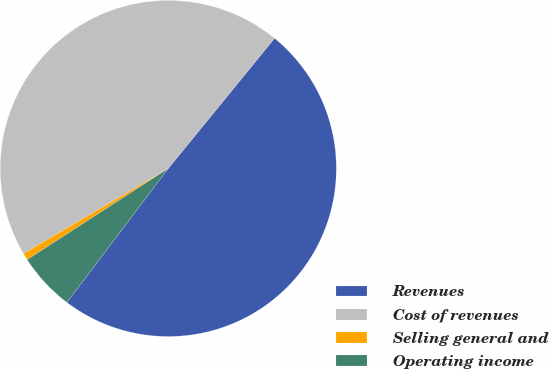Convert chart. <chart><loc_0><loc_0><loc_500><loc_500><pie_chart><fcel>Revenues<fcel>Cost of revenues<fcel>Selling general and<fcel>Operating income<nl><fcel>49.42%<fcel>44.36%<fcel>0.67%<fcel>5.55%<nl></chart> 